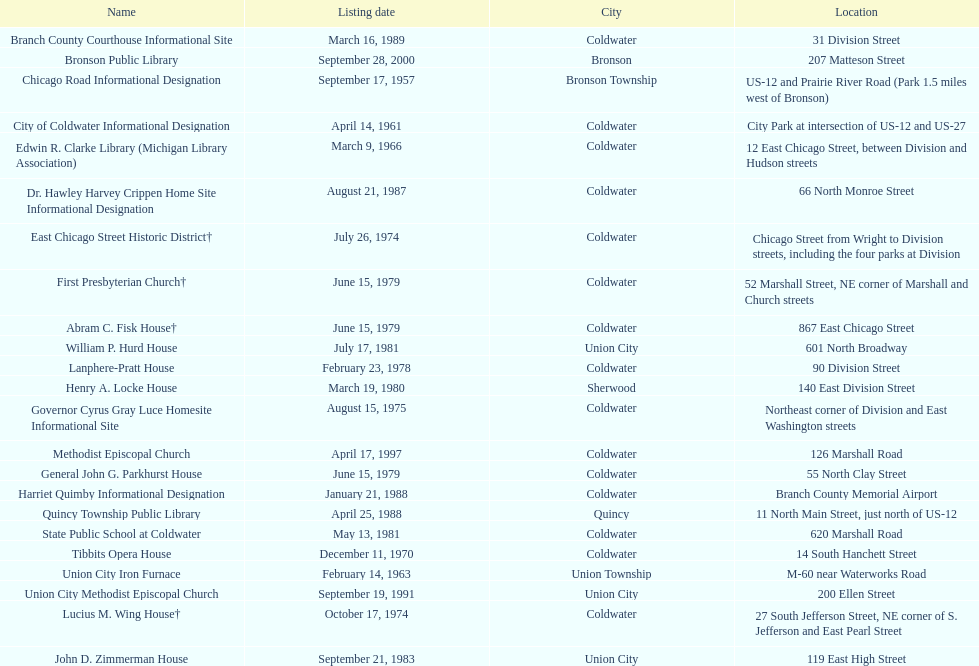How many historic sites are listed in coldwater? 15. 